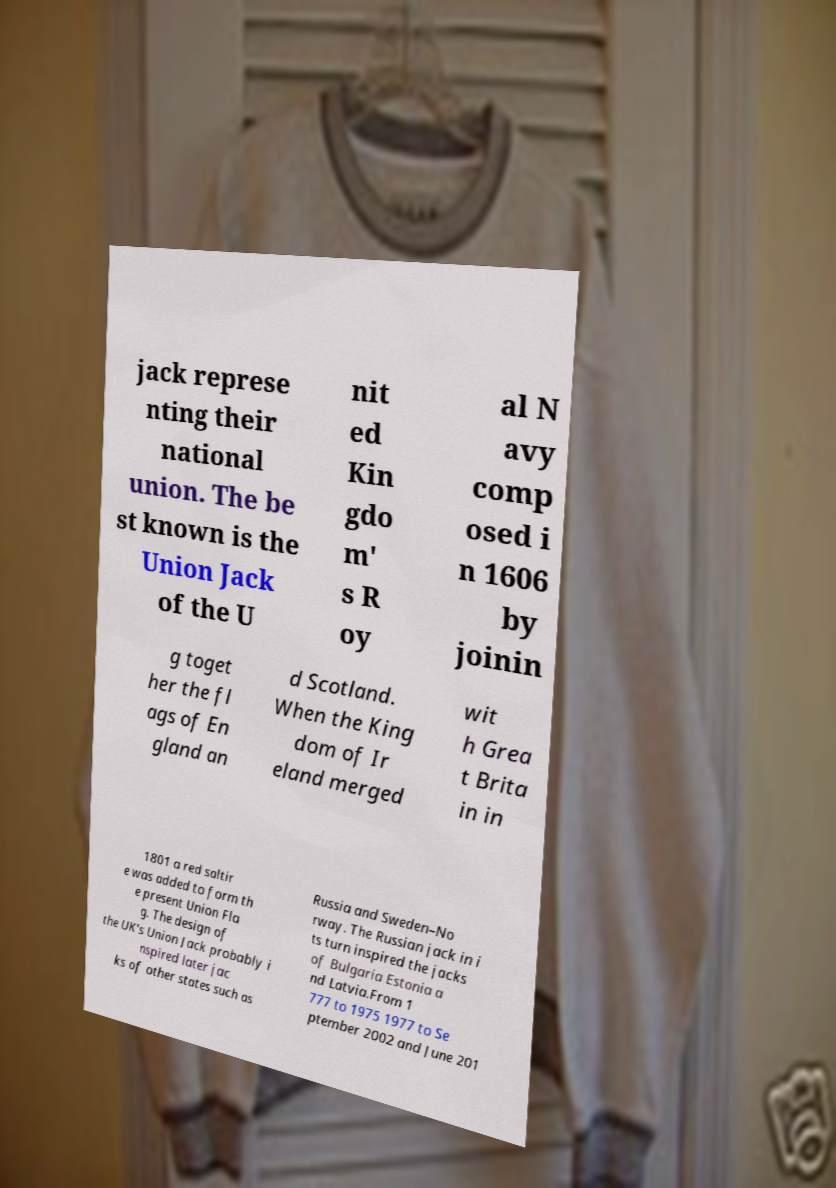There's text embedded in this image that I need extracted. Can you transcribe it verbatim? jack represe nting their national union. The be st known is the Union Jack of the U nit ed Kin gdo m' s R oy al N avy comp osed i n 1606 by joinin g toget her the fl ags of En gland an d Scotland. When the King dom of Ir eland merged wit h Grea t Brita in in 1801 a red saltir e was added to form th e present Union Fla g. The design of the UK's Union Jack probably i nspired later jac ks of other states such as Russia and Sweden–No rway. The Russian jack in i ts turn inspired the jacks of Bulgaria Estonia a nd Latvia.From 1 777 to 1975 1977 to Se ptember 2002 and June 201 